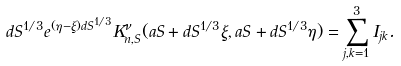<formula> <loc_0><loc_0><loc_500><loc_500>d S ^ { 1 / 3 } e ^ { ( \eta - \xi ) d S ^ { 1 / 3 } } K _ { n , S } ^ { \nu } ( a S + d S ^ { 1 / 3 } \xi , a S + d S ^ { 1 / 3 } \eta ) = \sum _ { j , k = 1 } ^ { 3 } I _ { j k } .</formula> 